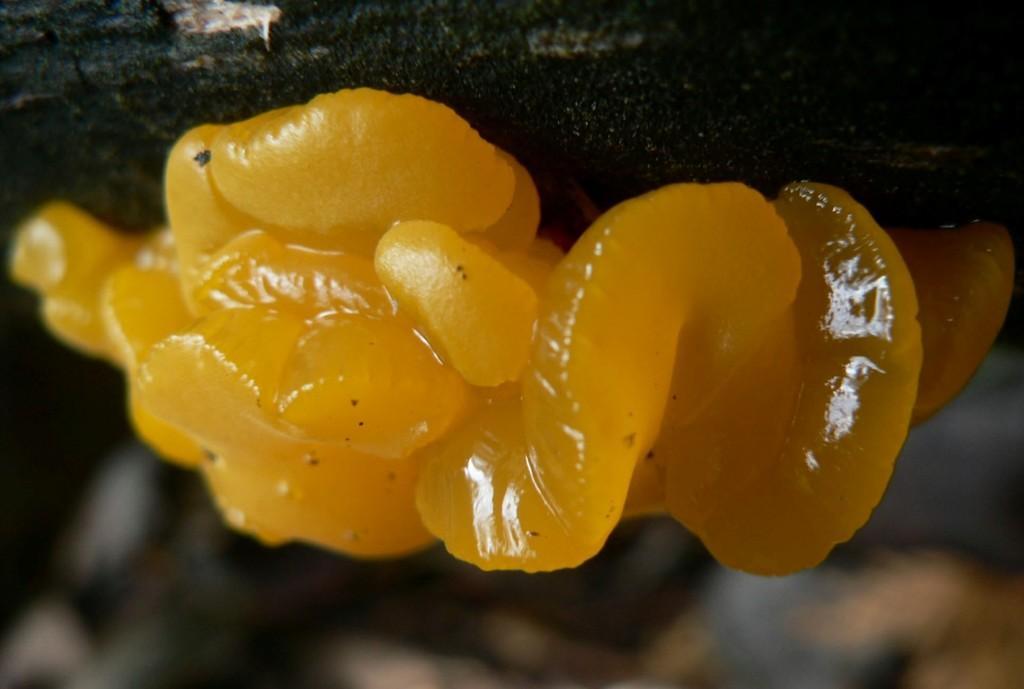Can you describe this image briefly? In this picture I can observe wood ear which is in yellow color. The background is completely blurred. 